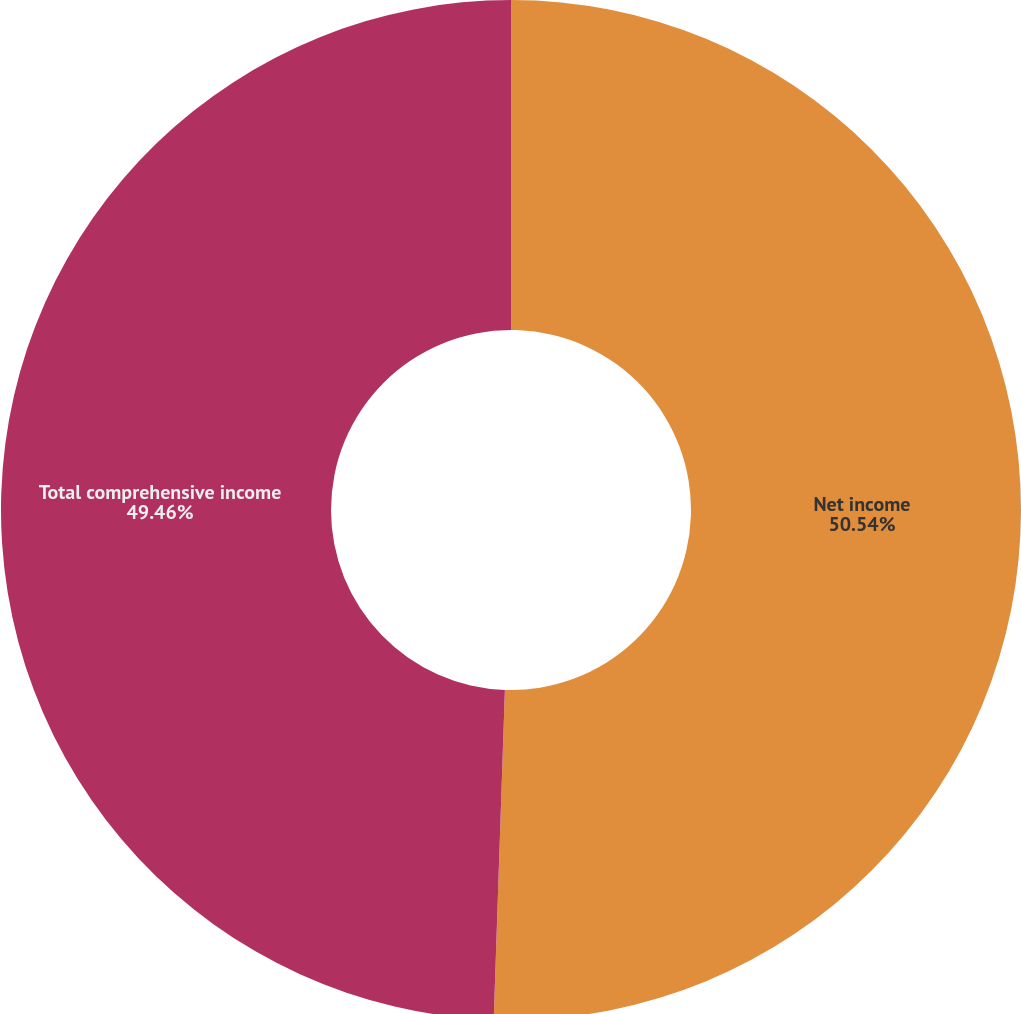Convert chart to OTSL. <chart><loc_0><loc_0><loc_500><loc_500><pie_chart><fcel>Net income<fcel>Total comprehensive income<nl><fcel>50.54%<fcel>49.46%<nl></chart> 